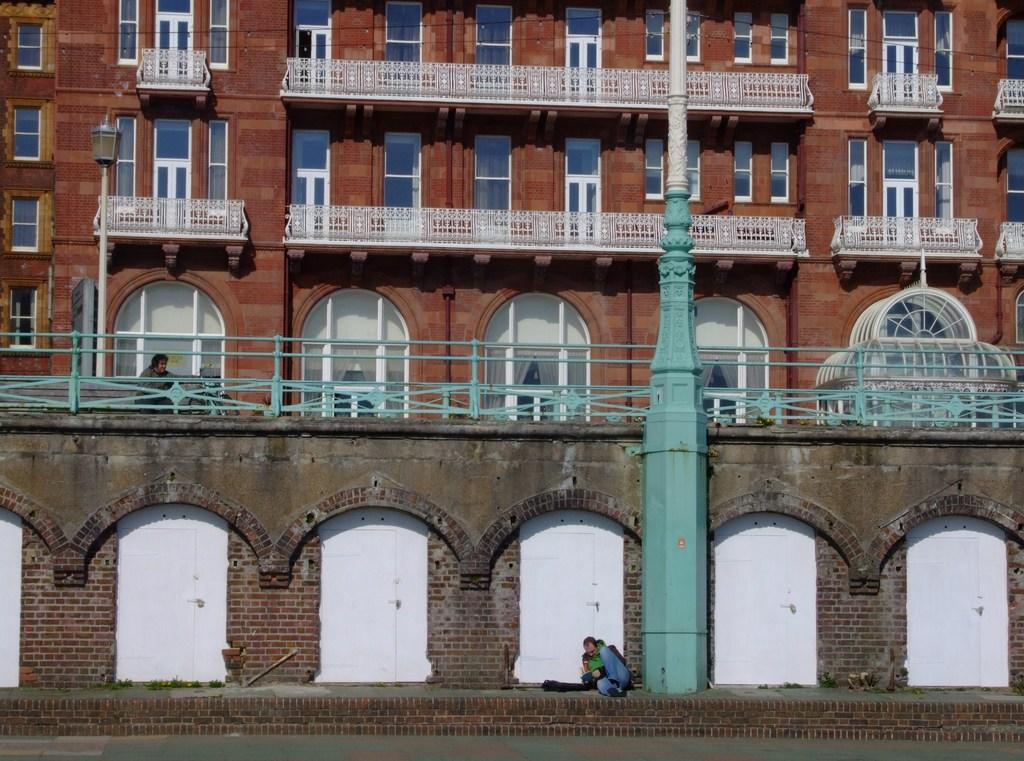What type of structure is visible in the image? There is a building in the image. What feature can be observed on the building? The building has glass windows. What is located near the building? There is a fence and a pole in the image. What is the purpose of the pole? The pole is a light pole. Can you describe the people in the image? There is a person standing in front of the wall and another person beside the light pole. What type of shoes is the person wearing in the image? There is no information about the person's shoes in the image. Can you tell me about the agreement between the two people in the image? There is no indication of any agreement between the two people in the image. 